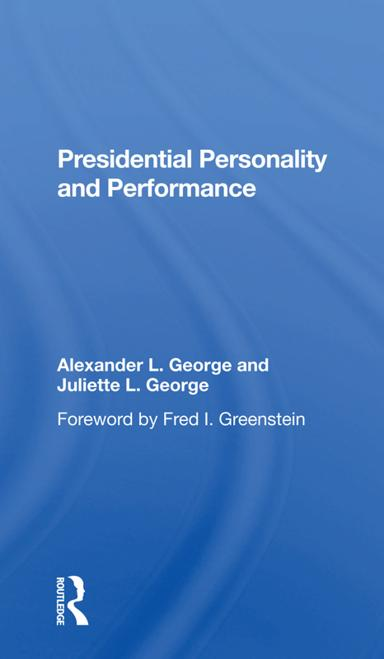What is the title of the book? The title of the book displayed in the image is 'Presidential Personality and Performance.' This book explores how the personal traits of presidents influence their effectiveness and policy-making decisions. 